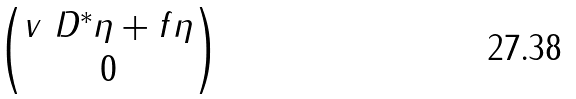<formula> <loc_0><loc_0><loc_500><loc_500>\begin{pmatrix} v \ D ^ { * } \eta + f \eta \\ 0 \end{pmatrix}</formula> 